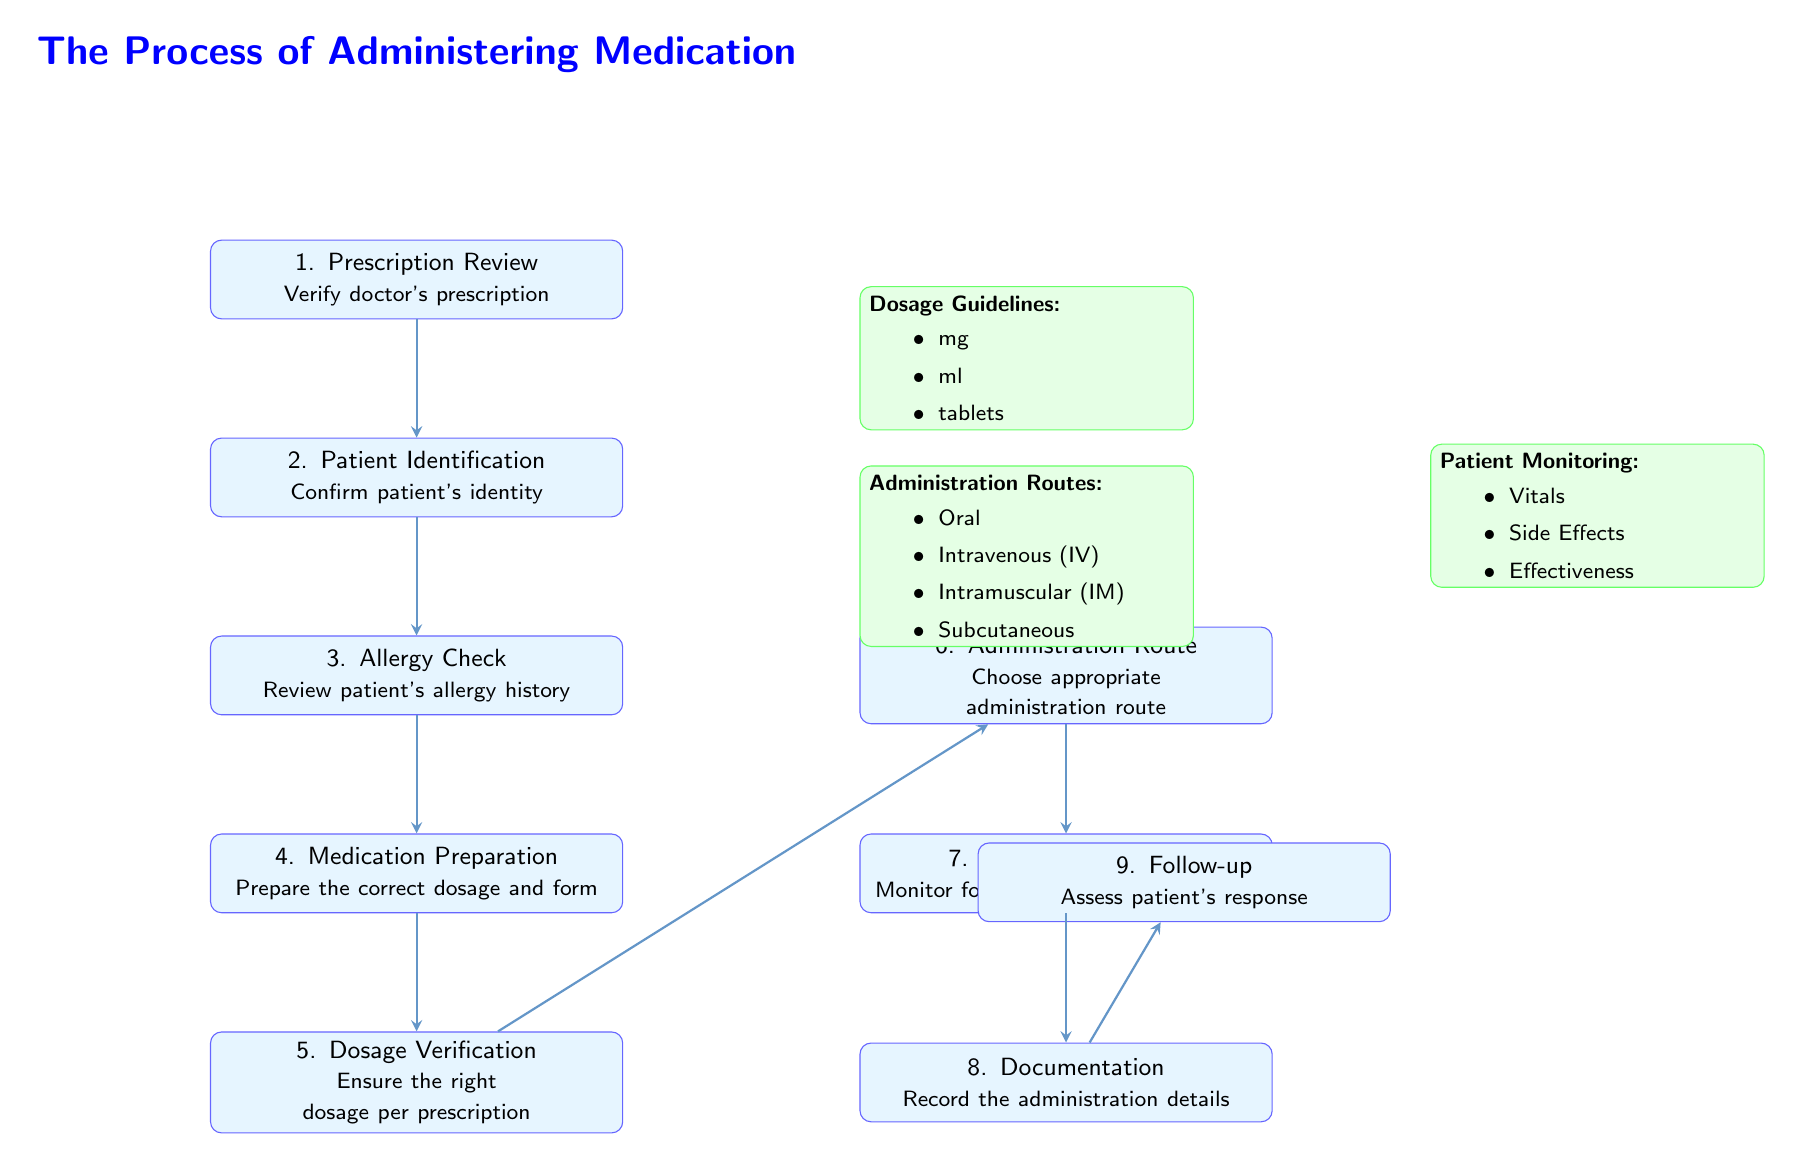What is the first step in the medication administration process? The first step in the diagram is "Prescription Review," which indicates verification of the doctor's prescription is needed.
Answer: Prescription Review How many nodes are present in the diagram? There are eight structured process nodes in the diagram, listing steps in the administration of medication.
Answer: Eight Which step follows "Allergy Check"? The step that follows "Allergy Check" is "Medication Preparation," as indicated by the directional arrow in the diagram.
Answer: Medication Preparation What is the purpose of the "Documentation" step? The "Documentation" step refers to recording the administration details after the medication has been given to the patient.
Answer: Record administration details In which step do we check for potential allergic reactions? The step designated for checking allergic reactions is "Allergy Check," where the patient's allergy history is reviewed.
Answer: Allergy Check What are the three administration routes mentioned in the diagram? The administration routes specified in the visual aids are Oral, Intravenous (IV), Intramuscular (IM), and Subcutaneous; three are selected for the answer.
Answer: Oral, Intravenous (IV), Intramuscular (IM) What information is necessary for "Dosage Verification"? "Dosage Verification" necessitates ensuring the right dosage per prescription, demanding a double-checking process.
Answer: Right dosage per prescription Describe the focus of "Patient Monitoring." "Patient Monitoring" focuses on evaluating vitals, examining side effects, and determining medication effectiveness after administration.
Answer: Vitals, Side Effects, Effectiveness What is assessed during the "Follow-up" step? The "Follow-up" step assesses the patient’s response after medication administration, determining outcomes and reactions.
Answer: Patient's response 